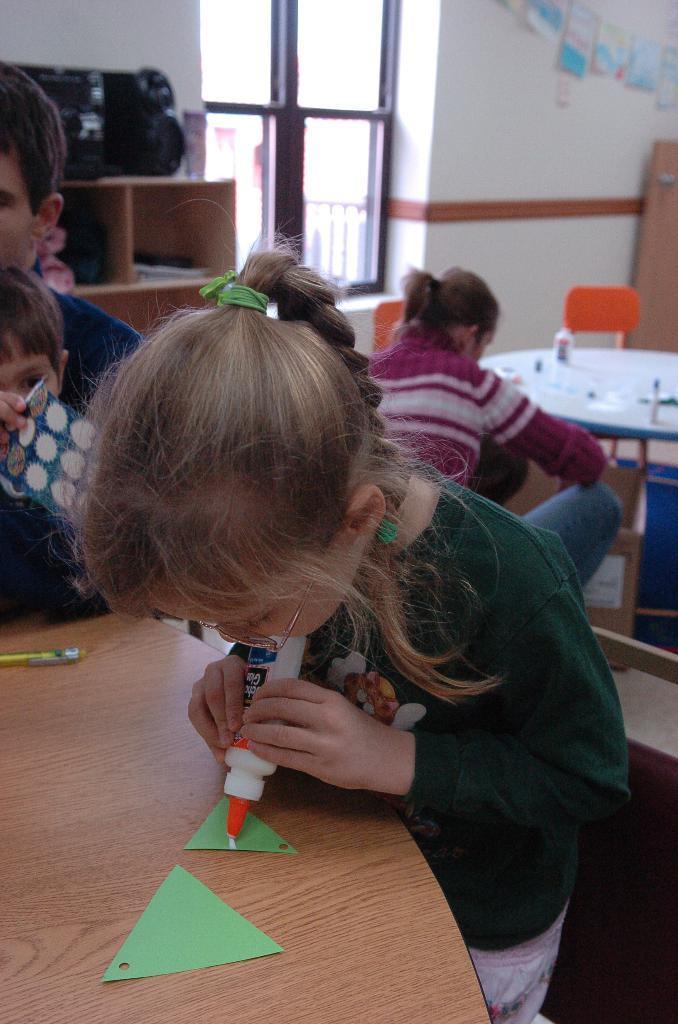Can you describe this image briefly? In this image we can see a girl is standing and she is wearing green color t-shirt and holding gum bottle in her hand. In front of her table is there. On table paper and pen is there. Background of the image one lady and two boys are there. We can see cupboard, table, chair, window, white color wall and black color thing in the background of the image. 